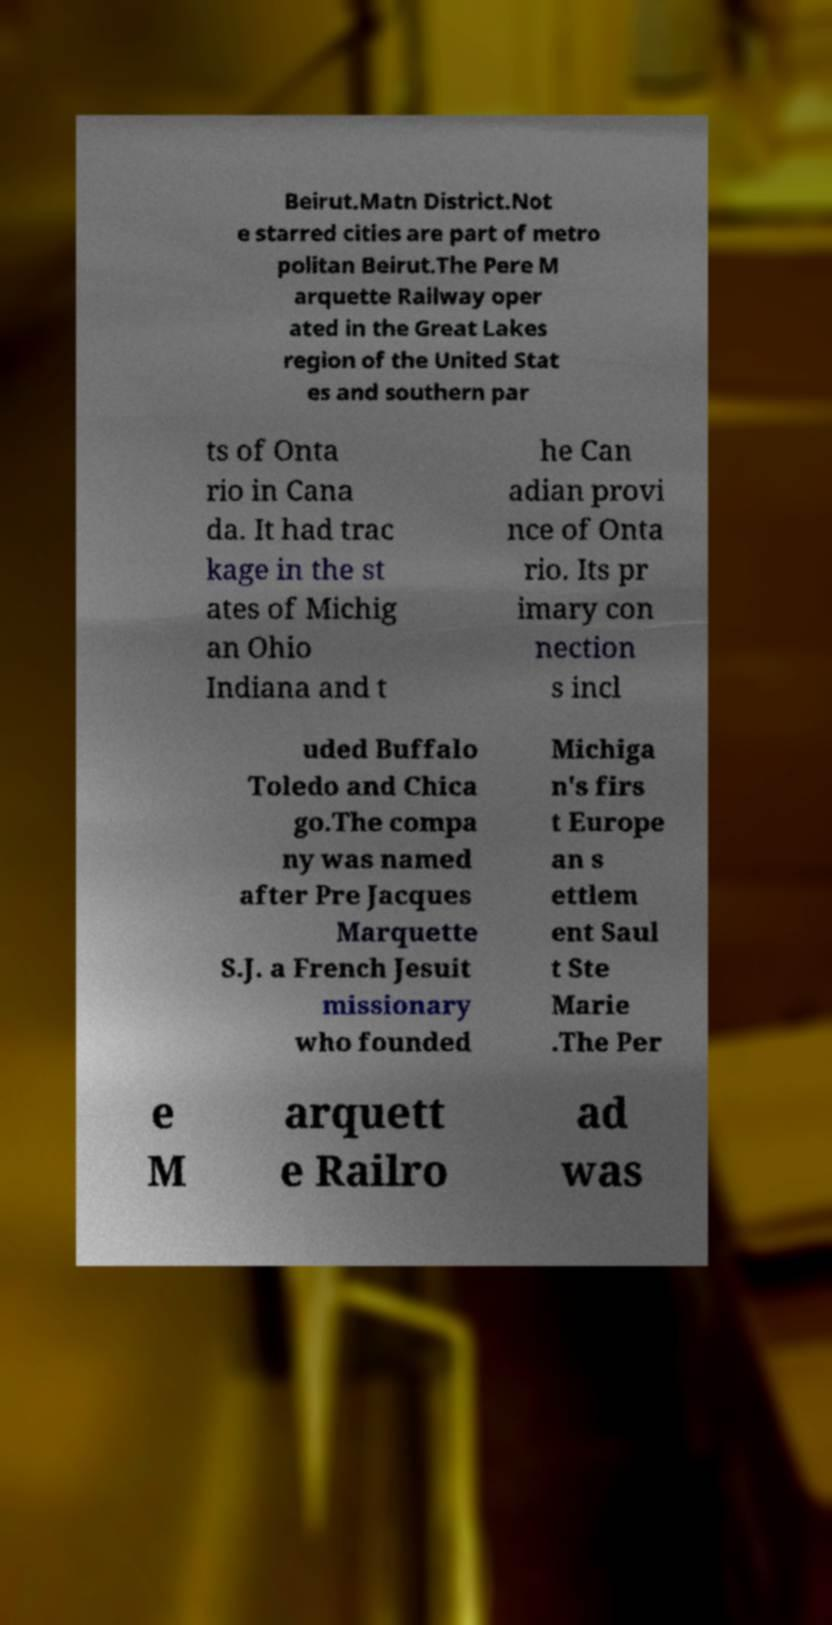What messages or text are displayed in this image? I need them in a readable, typed format. Beirut.Matn District.Not e starred cities are part of metro politan Beirut.The Pere M arquette Railway oper ated in the Great Lakes region of the United Stat es and southern par ts of Onta rio in Cana da. It had trac kage in the st ates of Michig an Ohio Indiana and t he Can adian provi nce of Onta rio. Its pr imary con nection s incl uded Buffalo Toledo and Chica go.The compa ny was named after Pre Jacques Marquette S.J. a French Jesuit missionary who founded Michiga n's firs t Europe an s ettlem ent Saul t Ste Marie .The Per e M arquett e Railro ad was 